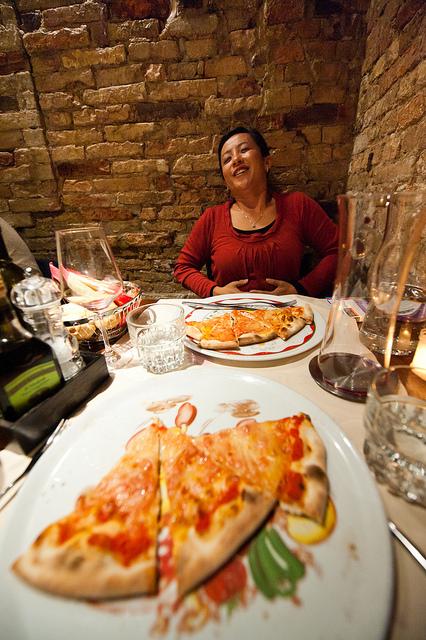Does the woman appear angry?
Concise answer only. No. Is the beer mug half full?
Write a very short answer. No. How many slices are on the closest plate?
Concise answer only. 3. What color is the woman's shirt?
Answer briefly. Red. 